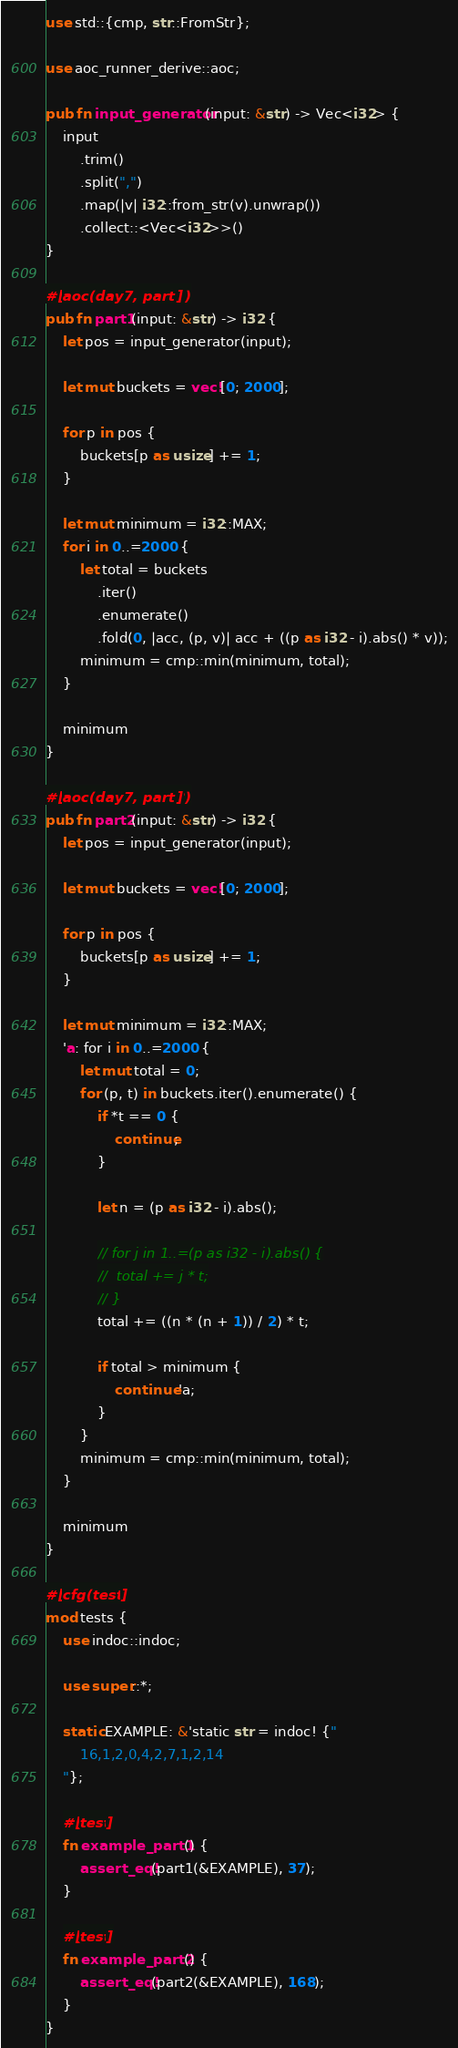Convert code to text. <code><loc_0><loc_0><loc_500><loc_500><_Rust_>use std::{cmp, str::FromStr};

use aoc_runner_derive::aoc;

pub fn input_generator(input: &str) -> Vec<i32> {
	input
		.trim()
		.split(",")
		.map(|v| i32::from_str(v).unwrap())
		.collect::<Vec<i32>>()
}

#[aoc(day7, part1)]
pub fn part1(input: &str) -> i32 {
	let pos = input_generator(input);

	let mut buckets = vec![0; 2000];

	for p in pos {
		buckets[p as usize] += 1;
	}

	let mut minimum = i32::MAX;
	for i in 0..=2000 {
		let total = buckets
			.iter()
			.enumerate()
			.fold(0, |acc, (p, v)| acc + ((p as i32 - i).abs() * v));
		minimum = cmp::min(minimum, total);
	}

	minimum
}

#[aoc(day7, part2)]
pub fn part2(input: &str) -> i32 {
	let pos = input_generator(input);

	let mut buckets = vec![0; 2000];

	for p in pos {
		buckets[p as usize] += 1;
	}

	let mut minimum = i32::MAX;
	'a: for i in 0..=2000 {
		let mut total = 0;
		for (p, t) in buckets.iter().enumerate() {
			if *t == 0 {
				continue;
			}

			let n = (p as i32 - i).abs();

			// for j in 1..=(p as i32 - i).abs() {
			// 	total += j * t;
			// }
			total += ((n * (n + 1)) / 2) * t;

			if total > minimum {
				continue 'a;
			}
		}
		minimum = cmp::min(minimum, total);
	}

	minimum
}

#[cfg(test)]
mod tests {
	use indoc::indoc;

	use super::*;

	static EXAMPLE: &'static str = indoc! {"
		16,1,2,0,4,2,7,1,2,14
	"};

	#[test]
	fn example_part1() {
		assert_eq!(part1(&EXAMPLE), 37);
	}

	#[test]
	fn example_part2() {
		assert_eq!(part2(&EXAMPLE), 168);
	}
}
</code> 